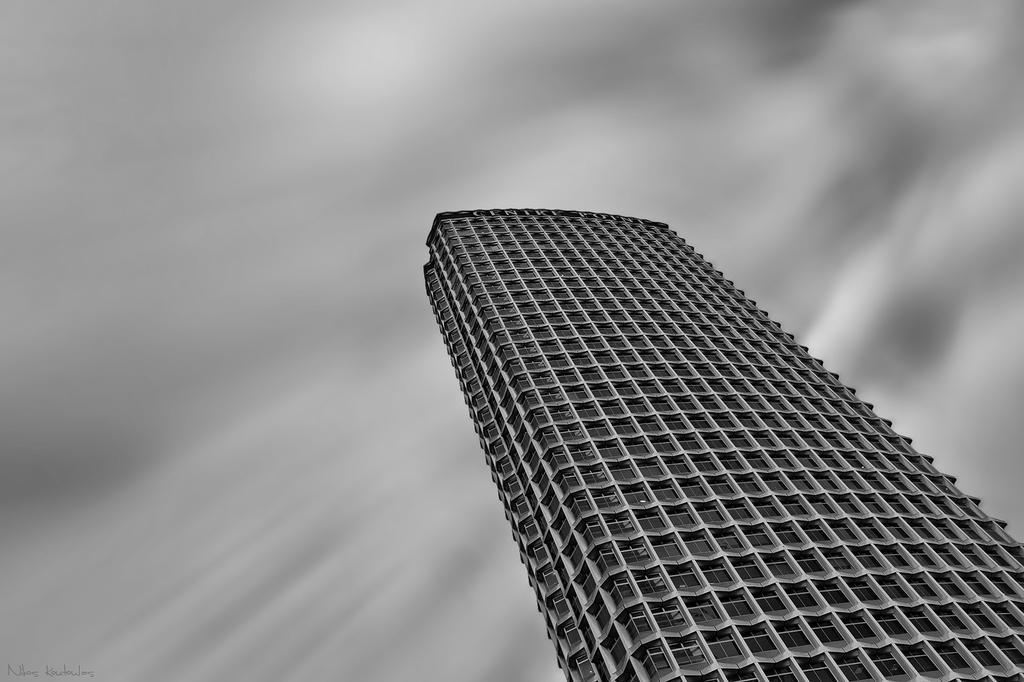Describe this image in one or two sentences. In the center of the image we can see a building, windows. In the background of the image we can see the clouds are present in the sky. In the bottom left corner we can see some text. 